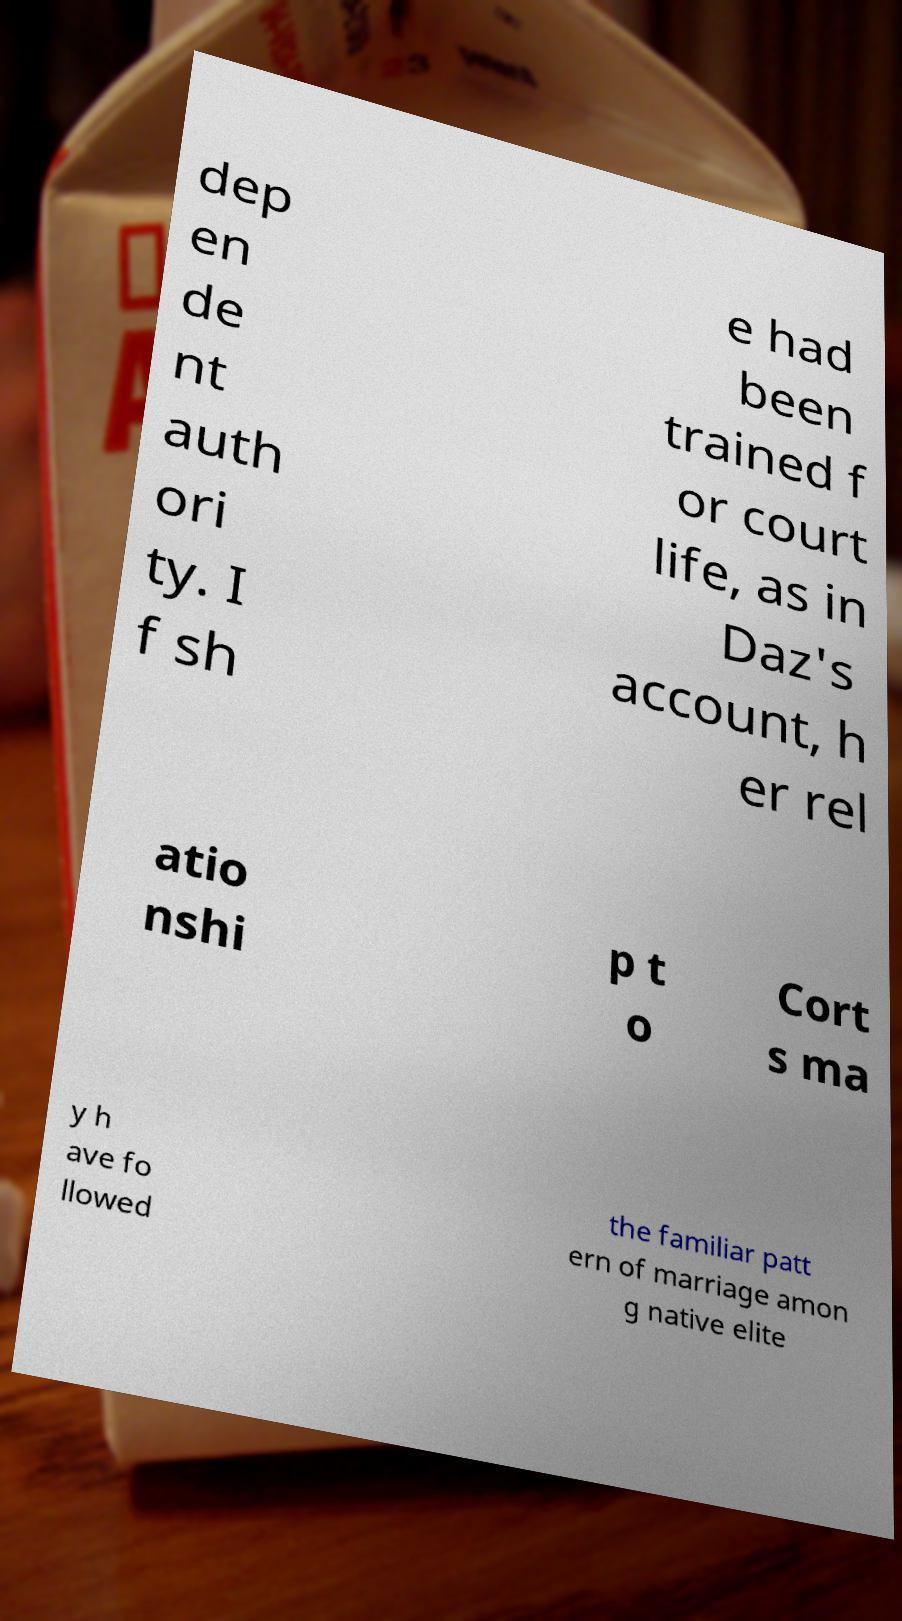Can you read and provide the text displayed in the image?This photo seems to have some interesting text. Can you extract and type it out for me? dep en de nt auth ori ty. I f sh e had been trained f or court life, as in Daz's account, h er rel atio nshi p t o Cort s ma y h ave fo llowed the familiar patt ern of marriage amon g native elite 